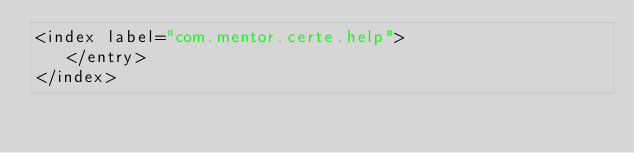<code> <loc_0><loc_0><loc_500><loc_500><_XML_><index label="com.mentor.certe.help">
   </entry>
</index>
</code> 